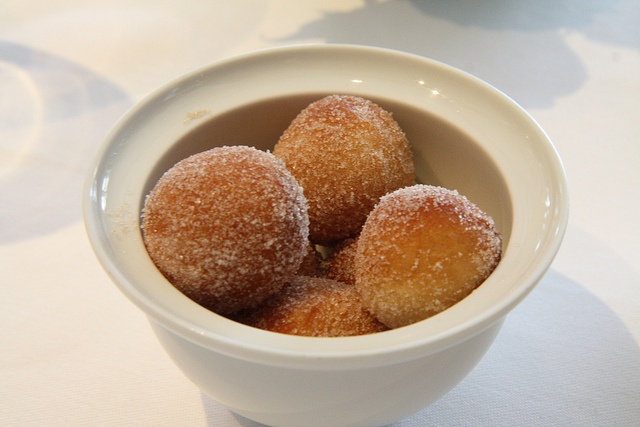Describe the objects in this image and their specific colors. I can see bowl in beige, tan, darkgray, brown, and gray tones, donut in beige, brown, gray, maroon, and tan tones, donut in beige, brown, salmon, and tan tones, donut in beige, brown, maroon, salmon, and tan tones, and donut in beige, brown, maroon, gray, and black tones in this image. 